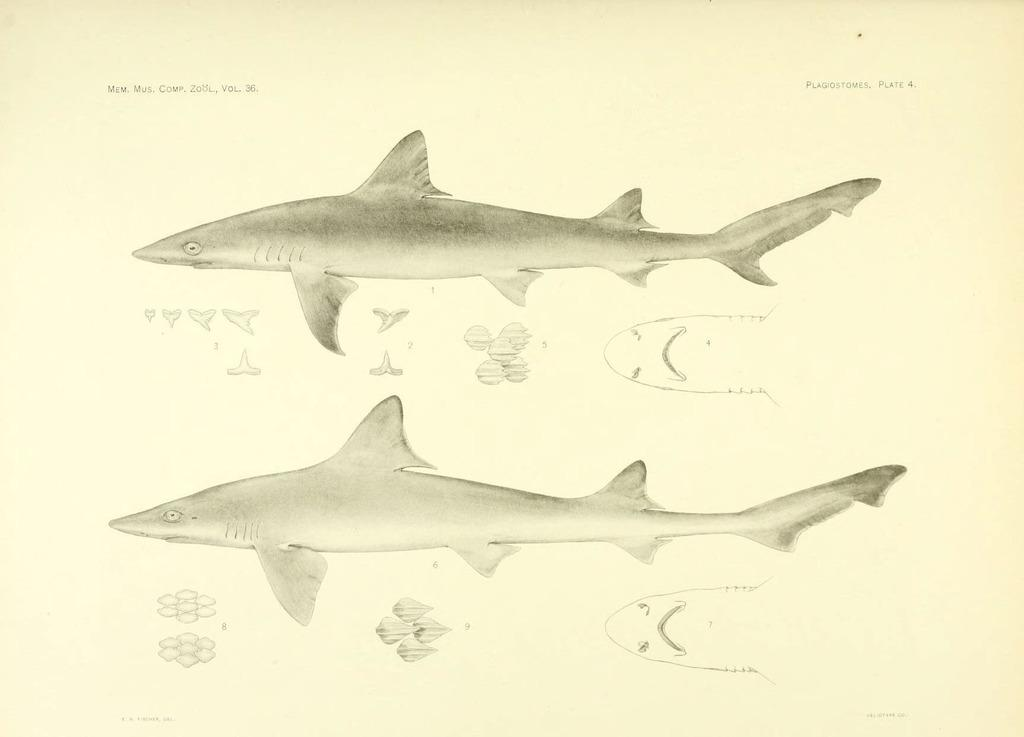What is depicted on the paper in the image? There is a drawing of sharks on a paper in the image. What type of teeth can be seen in the drawing of sharks? There are no teeth visible in the drawing of sharks, as it is a two-dimensional representation of sharks. 